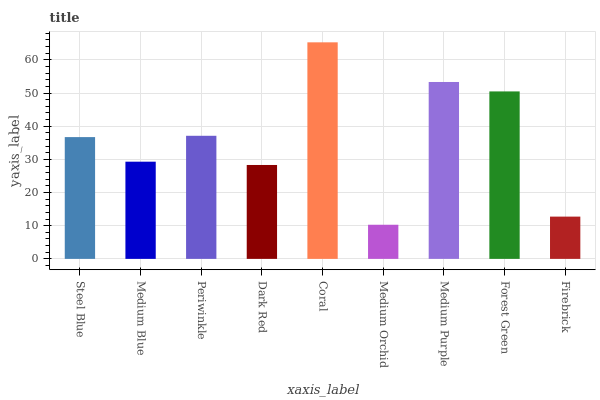Is Medium Orchid the minimum?
Answer yes or no. Yes. Is Coral the maximum?
Answer yes or no. Yes. Is Medium Blue the minimum?
Answer yes or no. No. Is Medium Blue the maximum?
Answer yes or no. No. Is Steel Blue greater than Medium Blue?
Answer yes or no. Yes. Is Medium Blue less than Steel Blue?
Answer yes or no. Yes. Is Medium Blue greater than Steel Blue?
Answer yes or no. No. Is Steel Blue less than Medium Blue?
Answer yes or no. No. Is Steel Blue the high median?
Answer yes or no. Yes. Is Steel Blue the low median?
Answer yes or no. Yes. Is Medium Blue the high median?
Answer yes or no. No. Is Periwinkle the low median?
Answer yes or no. No. 